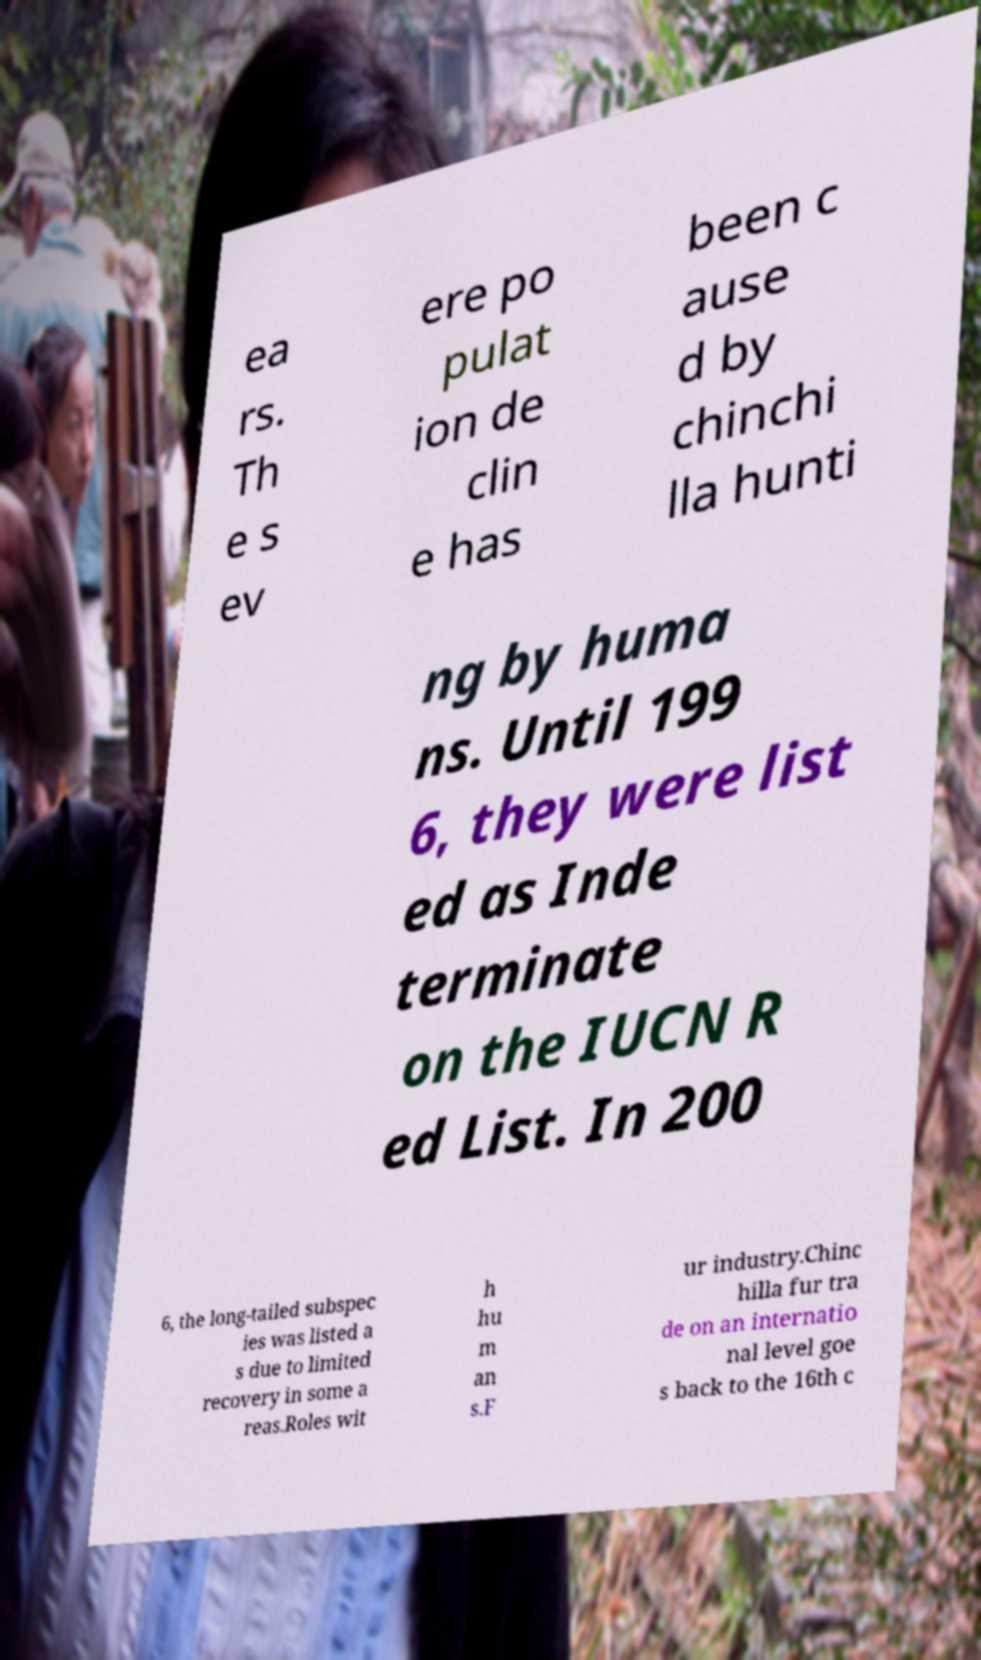Please read and relay the text visible in this image. What does it say? ea rs. Th e s ev ere po pulat ion de clin e has been c ause d by chinchi lla hunti ng by huma ns. Until 199 6, they were list ed as Inde terminate on the IUCN R ed List. In 200 6, the long-tailed subspec ies was listed a s due to limited recovery in some a reas.Roles wit h hu m an s.F ur industry.Chinc hilla fur tra de on an internatio nal level goe s back to the 16th c 